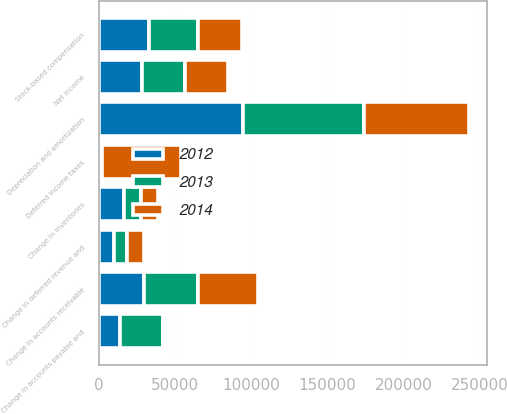<chart> <loc_0><loc_0><loc_500><loc_500><stacked_bar_chart><ecel><fcel>Net income<fcel>Depreciation and amortization<fcel>Stock-based compensation<fcel>Deferred income taxes<fcel>Change in accounts receivable<fcel>Change in inventories<fcel>Change in accounts payable and<fcel>Change in deferred revenue and<nl><fcel>2012<fcel>28127<fcel>94231<fcel>32998<fcel>1583<fcel>29435<fcel>15984<fcel>13687<fcel>9566<nl><fcel>2013<fcel>28127<fcel>79695<fcel>31708<fcel>169<fcel>35233<fcel>11389<fcel>28127<fcel>8512<nl><fcel>2014<fcel>28127<fcel>68831<fcel>29183<fcel>52219<fcel>39836<fcel>10930<fcel>563<fcel>11005<nl></chart> 